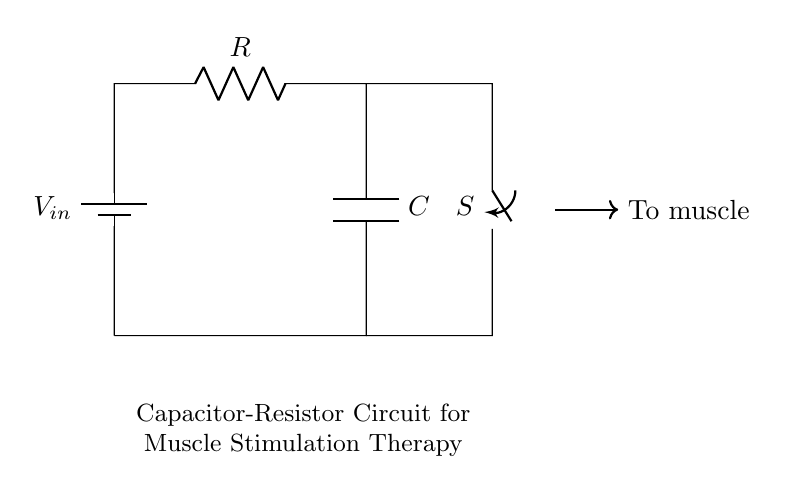What is the input voltage of this circuit? The input voltage, represented by the symbol \( V_{in} \), is specified in the circuit diagram but not provided a specific value. Thus, it could be any applied voltage depending on the system design.
Answer: \( V_{in} \) What type of components are connected in this circuit? The circuit consists of a battery (providing input voltage), a resistor connected in series with a capacitor, and a closing switch. Each component plays a vital role in the operation of the circuit for muscle stimulation.
Answer: Battery, resistor, capacitor, switch What happens when the switch is closed? Closing the switch allows current to flow through the circuit. This change affects the charge on the capacitor and the voltage across the capacitor and resistor, which is crucial for the muscle stimulation effect.
Answer: Current flows What is the role of the resistor in this circuit? The resistor limits the current flowing in the circuit. This is important for properly controlling the current delivered to the muscles during stimulation to avoid potential damage.
Answer: Current limiting What type of circuit is represented here? The circuit is an RC circuit, specifically a capacitor-resistor combination. This configuration is commonly used for timing applications, filtering signals, and in this context, for muscle stimulation therapy.
Answer: RC circuit How does the capacitor affect muscle stimulation? The capacitor stores and releases energy, allowing for a controlled delivery of pulses to the muscles. This pulsing action is critical in muscle stimulation therapy, as it simulates natural muscle contractions.
Answer: Energy storage 